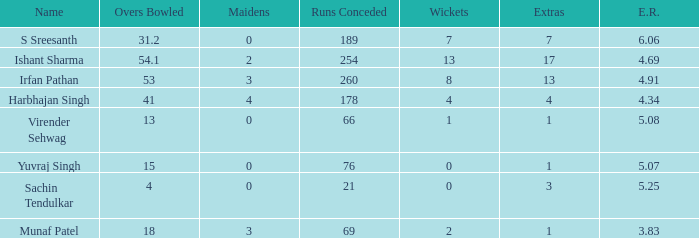Name the total number of wickets being yuvraj singh 1.0. 